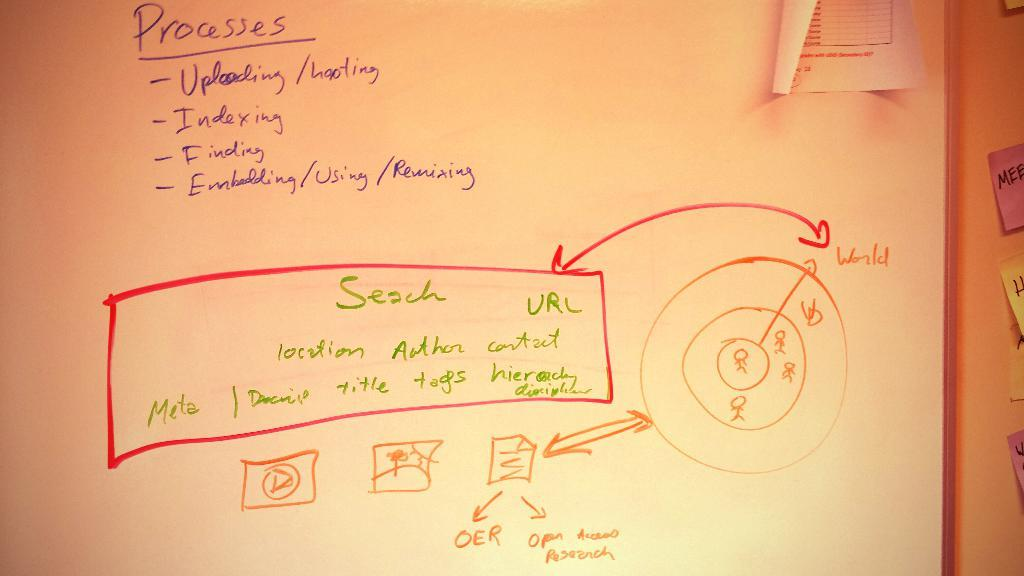Provide a one-sentence caption for the provided image. A whiteboard displaying the processes for uploading files to a server. 